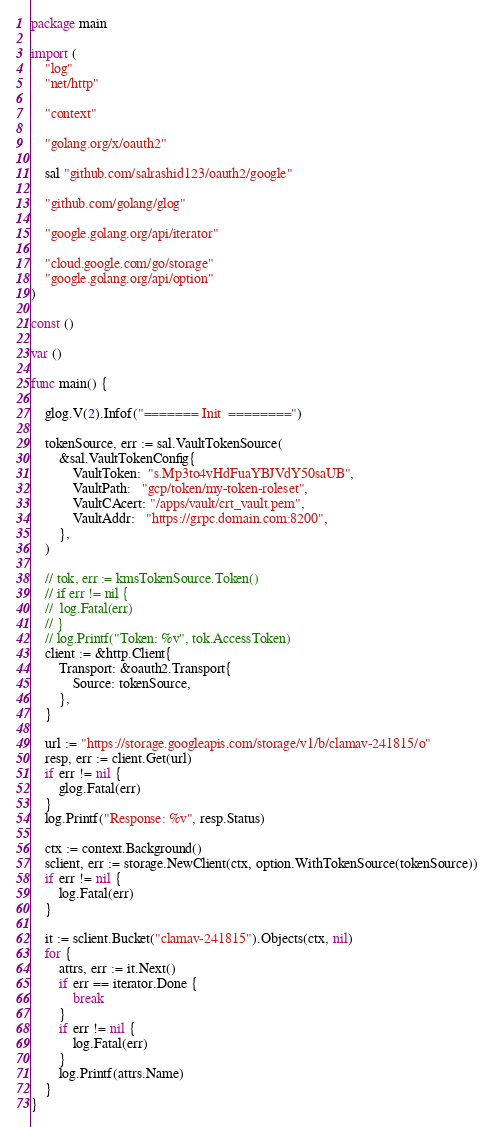<code> <loc_0><loc_0><loc_500><loc_500><_Go_>package main

import (
	"log"
	"net/http"

	"context"

	"golang.org/x/oauth2"

	sal "github.com/salrashid123/oauth2/google"

	"github.com/golang/glog"

	"google.golang.org/api/iterator"

	"cloud.google.com/go/storage"
	"google.golang.org/api/option"
)

const ()

var ()

func main() {

	glog.V(2).Infof("======= Init  ========")

	tokenSource, err := sal.VaultTokenSource(
		&sal.VaultTokenConfig{
			VaultToken:  "s.Mp3to4vHdFuaYBJVdY50saUB",
			VaultPath:   "gcp/token/my-token-roleset",
			VaultCAcert: "/apps/vault/crt_vault.pem",
			VaultAddr:   "https://grpc.domain.com:8200",
		},
	)

	// tok, err := kmsTokenSource.Token()
	// if err != nil {
	// 	log.Fatal(err)
	// }
	// log.Printf("Token: %v", tok.AccessToken)
	client := &http.Client{
		Transport: &oauth2.Transport{
			Source: tokenSource,
		},
	}

	url := "https://storage.googleapis.com/storage/v1/b/clamav-241815/o"
	resp, err := client.Get(url)
	if err != nil {
		glog.Fatal(err)
	}
	log.Printf("Response: %v", resp.Status)

	ctx := context.Background()
	sclient, err := storage.NewClient(ctx, option.WithTokenSource(tokenSource))
	if err != nil {
		log.Fatal(err)
	}

	it := sclient.Bucket("clamav-241815").Objects(ctx, nil)
	for {
		attrs, err := it.Next()
		if err == iterator.Done {
			break
		}
		if err != nil {
			log.Fatal(err)
		}
		log.Printf(attrs.Name)
	}
}
</code> 